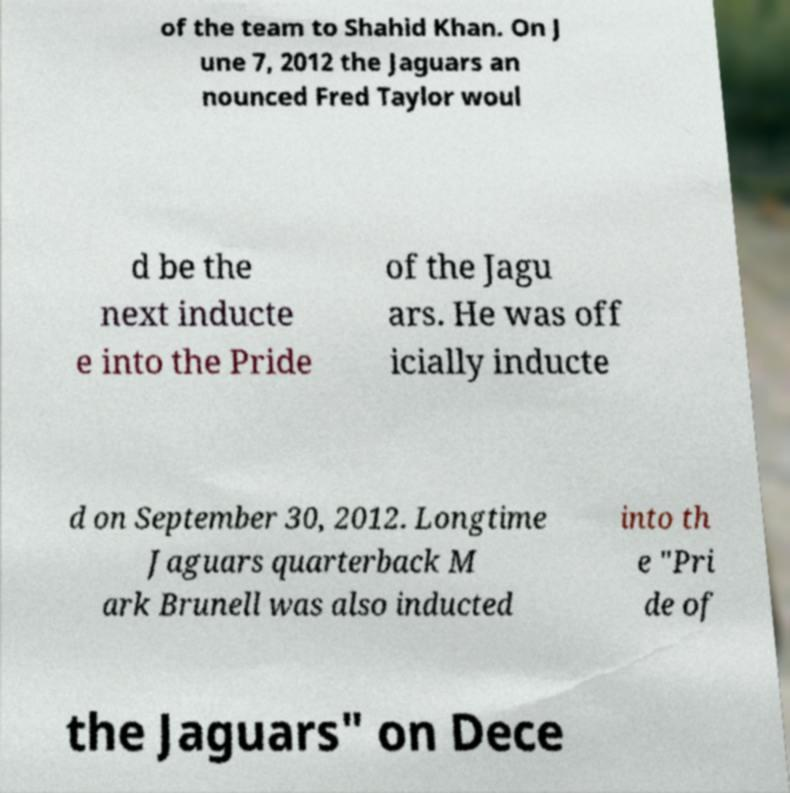For documentation purposes, I need the text within this image transcribed. Could you provide that? of the team to Shahid Khan. On J une 7, 2012 the Jaguars an nounced Fred Taylor woul d be the next inducte e into the Pride of the Jagu ars. He was off icially inducte d on September 30, 2012. Longtime Jaguars quarterback M ark Brunell was also inducted into th e "Pri de of the Jaguars" on Dece 